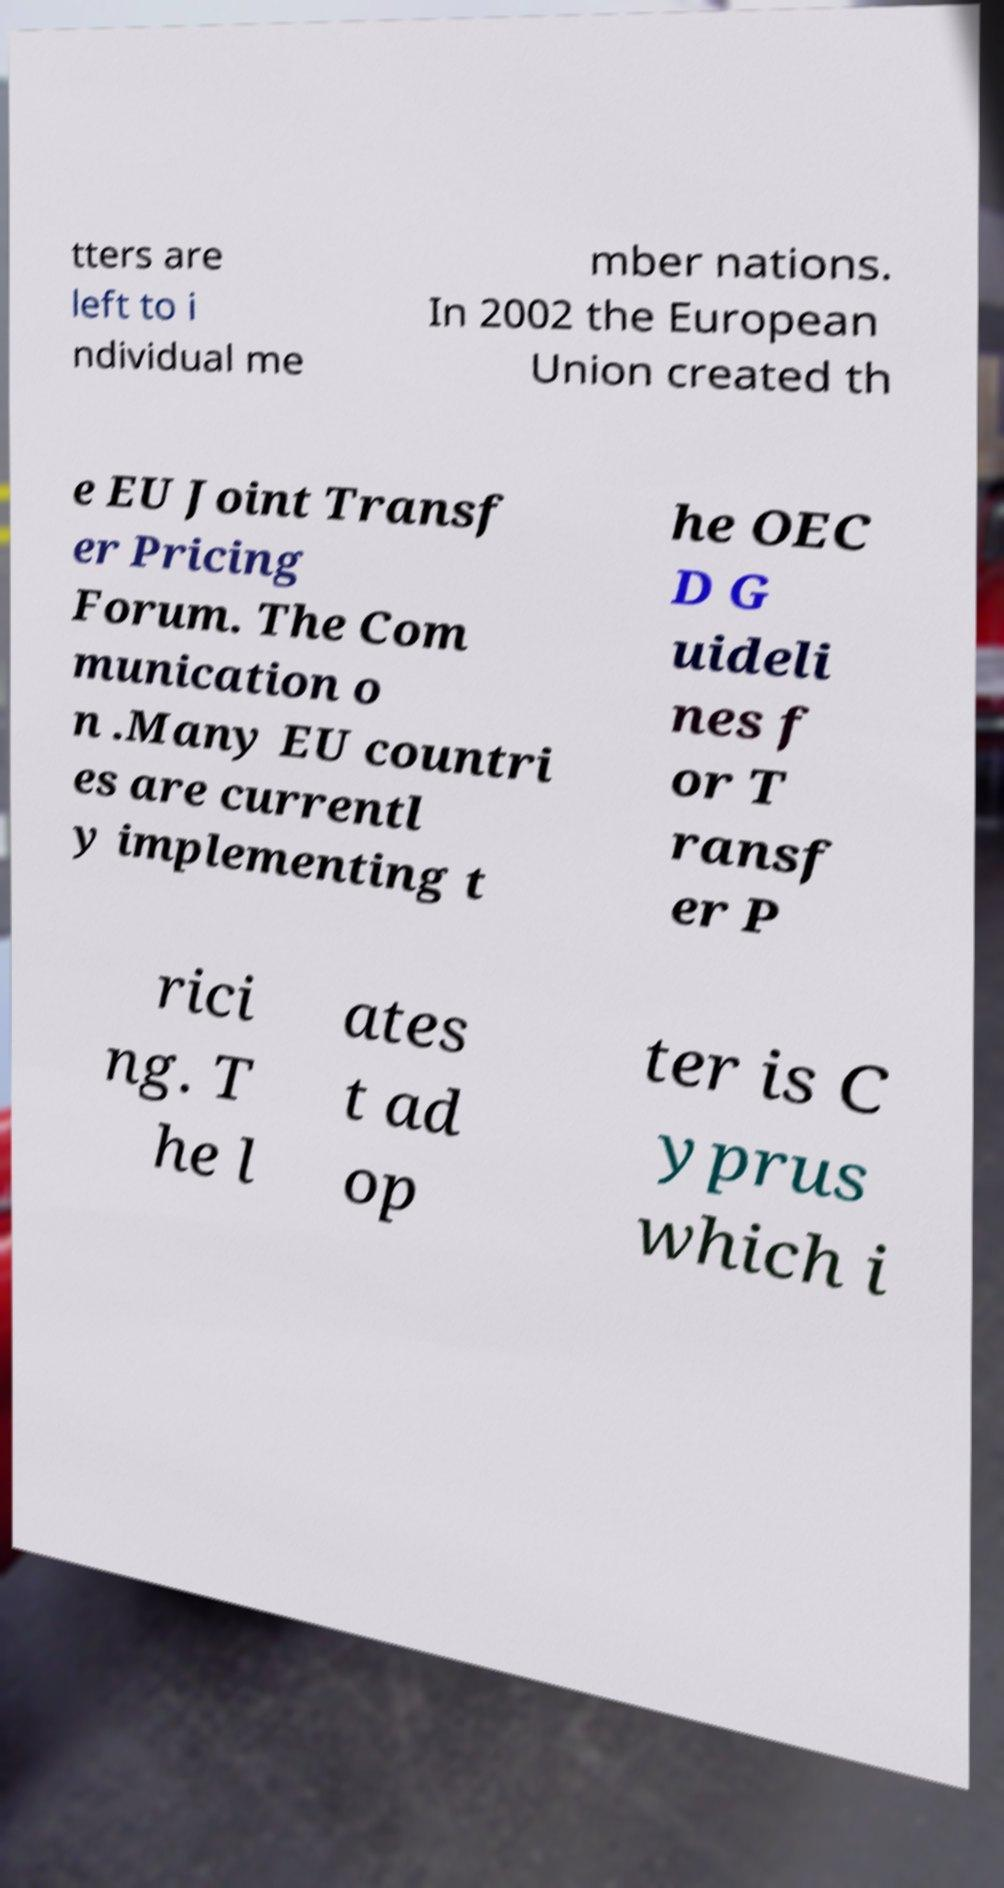Could you assist in decoding the text presented in this image and type it out clearly? tters are left to i ndividual me mber nations. In 2002 the European Union created th e EU Joint Transf er Pricing Forum. The Com munication o n .Many EU countri es are currentl y implementing t he OEC D G uideli nes f or T ransf er P rici ng. T he l ates t ad op ter is C yprus which i 